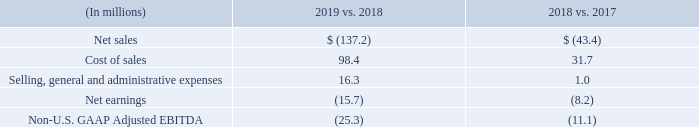Foreign Currency Translation Impact on Consolidated Financial Results
Since we are a U.S. domiciled company, we translate our foreign currency-denominated financial results into US Dollars. Due to the changes in the value of foreign currencies relative to the US Dollar, translating our financial results from foreign currencies to US Dollars may result in a favorable or unfavorable impact. Historically, the most significant currencies that have impacted the translation of our consolidated financial results are the euro, the Australian dollar, the Mexican peso, the British pound, the Canadian dollar, the Brazilian real and the Chinese Renminbi.
The following table presents the approximate favorable or (unfavorable) impact foreign currency translation had on certain of our consolidated financial results
What currency is translated to by the company for financial results? Us dollars. Historically, what currencies have impacted  the translation of their consolidated financial results most significantly? Euro, the australian dollar, the mexican peso, the british pound, the canadian dollar, the brazilian real and the chinese renminbi. What does the table show? The following table presents the approximate favorable or (unfavorable) impact foreign currency translation had on certain of our consolidated financial results. What is the total favourable impact foreign currency translation had on certain of their consolidated financial results? 
Answer scale should be: million. 98.4+31.7+16.3+1.0
Answer: 147.4. What is the difference between the impact of cost of sales for 2019 vs. 2018 and 2018 vs. 2017?
Answer scale should be: million. 98.4-31.7
Answer: 66.7. What is the percentage change of the impact of Net sales of 2019 vs. 2018 from 2018 vs. 2017?
Answer scale should be: percent. (137.2-43.4)/43.4
Answer: 216.13. 